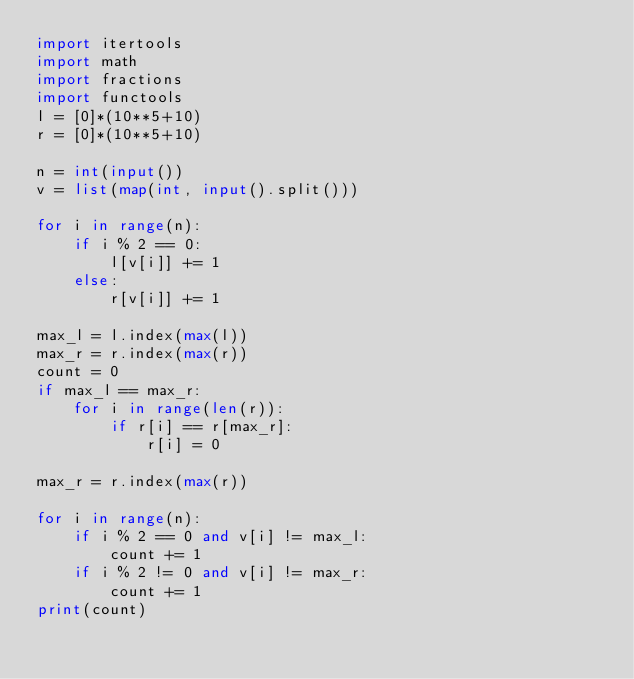<code> <loc_0><loc_0><loc_500><loc_500><_Python_>import itertools
import math
import fractions
import functools
l = [0]*(10**5+10)
r = [0]*(10**5+10)

n = int(input())
v = list(map(int, input().split()))

for i in range(n):
    if i % 2 == 0:
        l[v[i]] += 1
    else:
        r[v[i]] += 1

max_l = l.index(max(l))
max_r = r.index(max(r))
count = 0
if max_l == max_r:
    for i in range(len(r)):
        if r[i] == r[max_r]:
            r[i] = 0

max_r = r.index(max(r))

for i in range(n):
    if i % 2 == 0 and v[i] != max_l:
        count += 1
    if i % 2 != 0 and v[i] != max_r:
        count += 1
print(count)</code> 